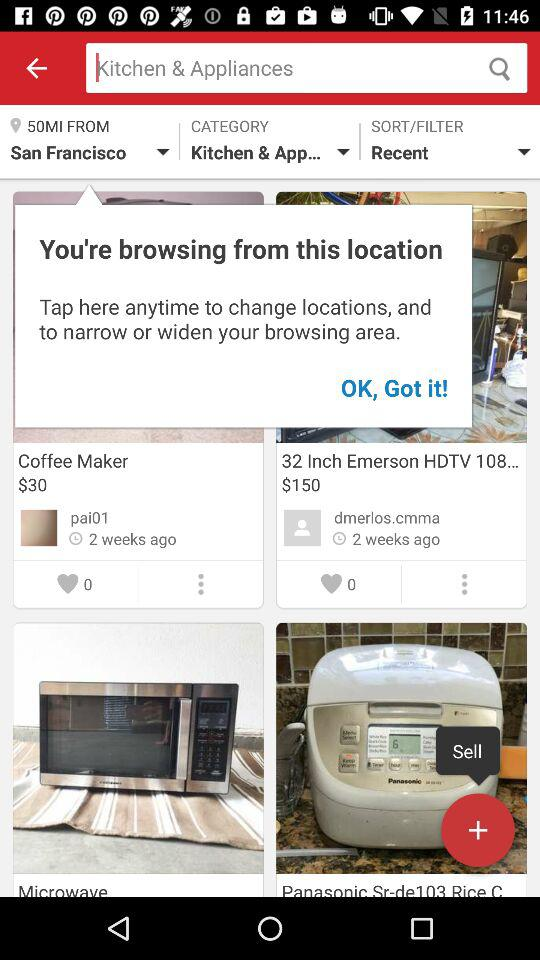How many likes are given there for "Coffee Maker"? There are 0 likes for Coffee Maker. 